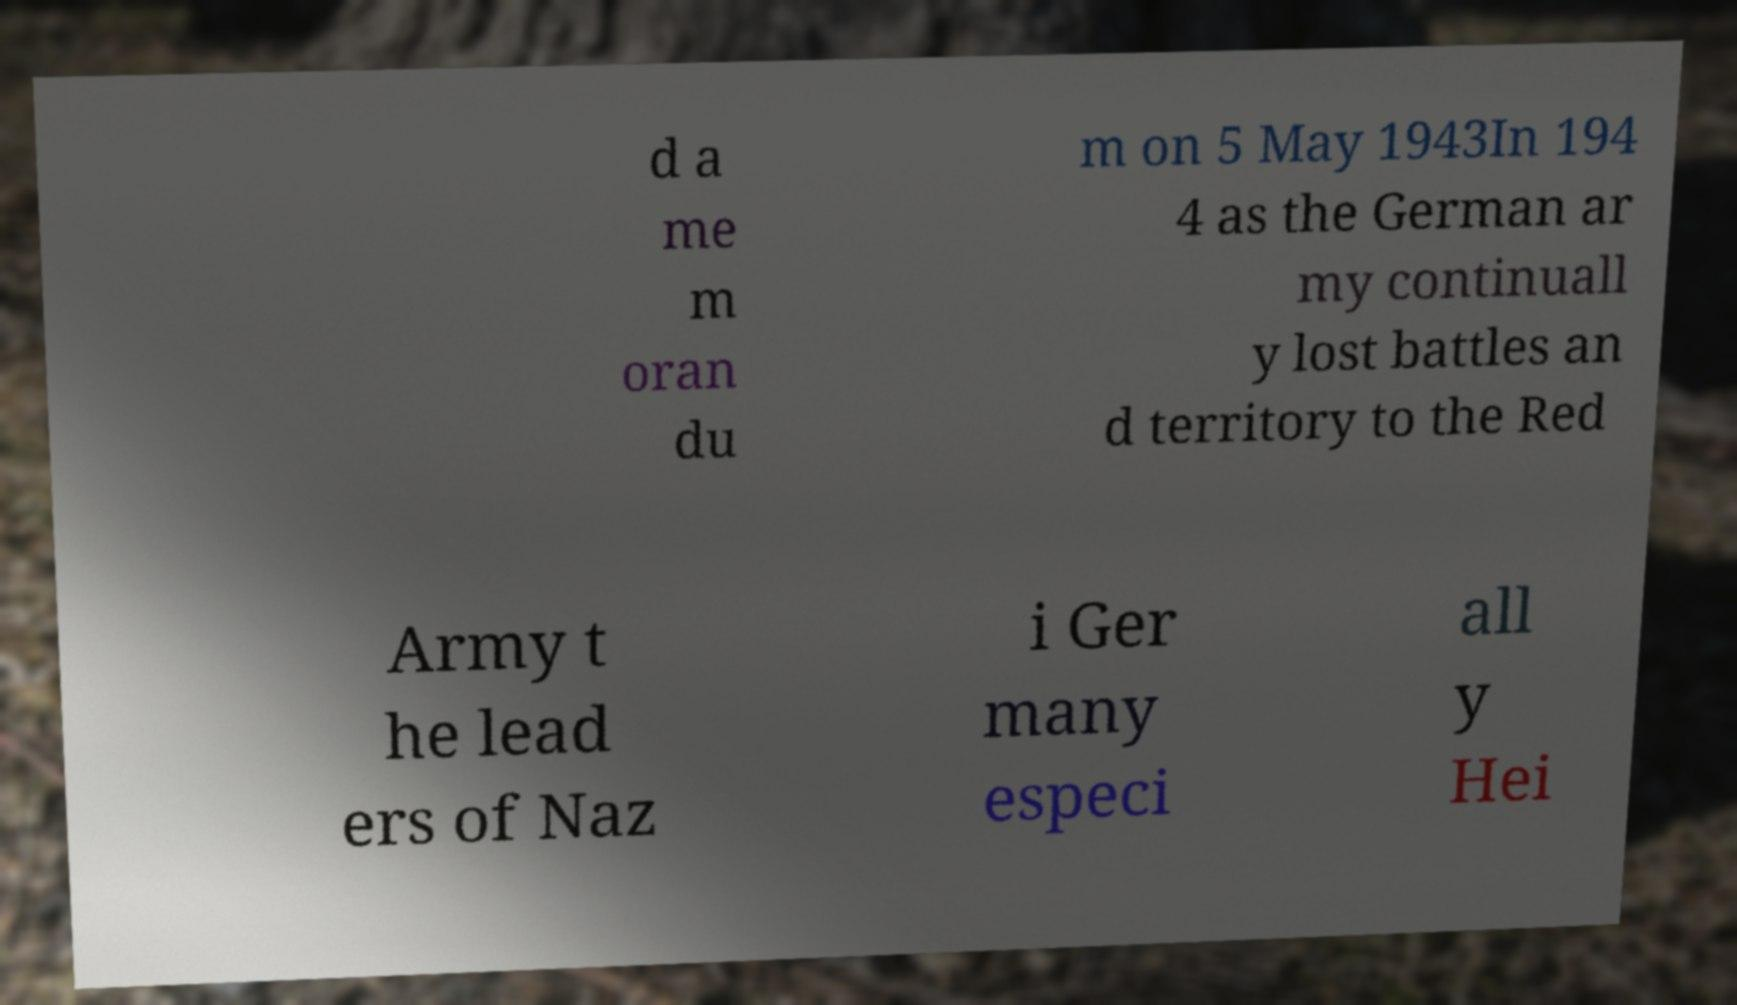There's text embedded in this image that I need extracted. Can you transcribe it verbatim? d a me m oran du m on 5 May 1943In 194 4 as the German ar my continuall y lost battles an d territory to the Red Army t he lead ers of Naz i Ger many especi all y Hei 